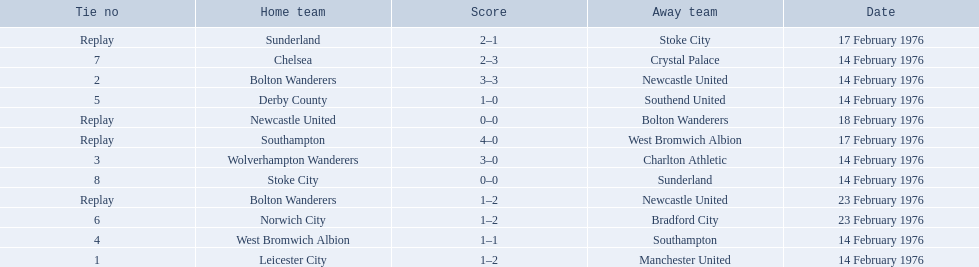What is the game at the top of the table? 1. I'm looking to parse the entire table for insights. Could you assist me with that? {'header': ['Tie no', 'Home team', 'Score', 'Away team', 'Date'], 'rows': [['Replay', 'Sunderland', '2–1', 'Stoke City', '17 February 1976'], ['7', 'Chelsea', '2–3', 'Crystal Palace', '14 February 1976'], ['2', 'Bolton Wanderers', '3–3', 'Newcastle United', '14 February 1976'], ['5', 'Derby County', '1–0', 'Southend United', '14 February 1976'], ['Replay', 'Newcastle United', '0–0', 'Bolton Wanderers', '18 February 1976'], ['Replay', 'Southampton', '4–0', 'West Bromwich Albion', '17 February 1976'], ['3', 'Wolverhampton Wanderers', '3–0', 'Charlton Athletic', '14 February 1976'], ['8', 'Stoke City', '0–0', 'Sunderland', '14 February 1976'], ['Replay', 'Bolton Wanderers', '1–2', 'Newcastle United', '23 February 1976'], ['6', 'Norwich City', '1–2', 'Bradford City', '23 February 1976'], ['4', 'West Bromwich Albion', '1–1', 'Southampton', '14 February 1976'], ['1', 'Leicester City', '1–2', 'Manchester United', '14 February 1976']]} Who is the home team for this game? Leicester City. 